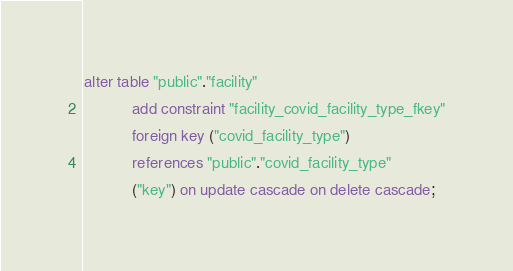<code> <loc_0><loc_0><loc_500><loc_500><_SQL_>alter table "public"."facility"
           add constraint "facility_covid_facility_type_fkey"
           foreign key ("covid_facility_type")
           references "public"."covid_facility_type"
           ("key") on update cascade on delete cascade;
</code> 